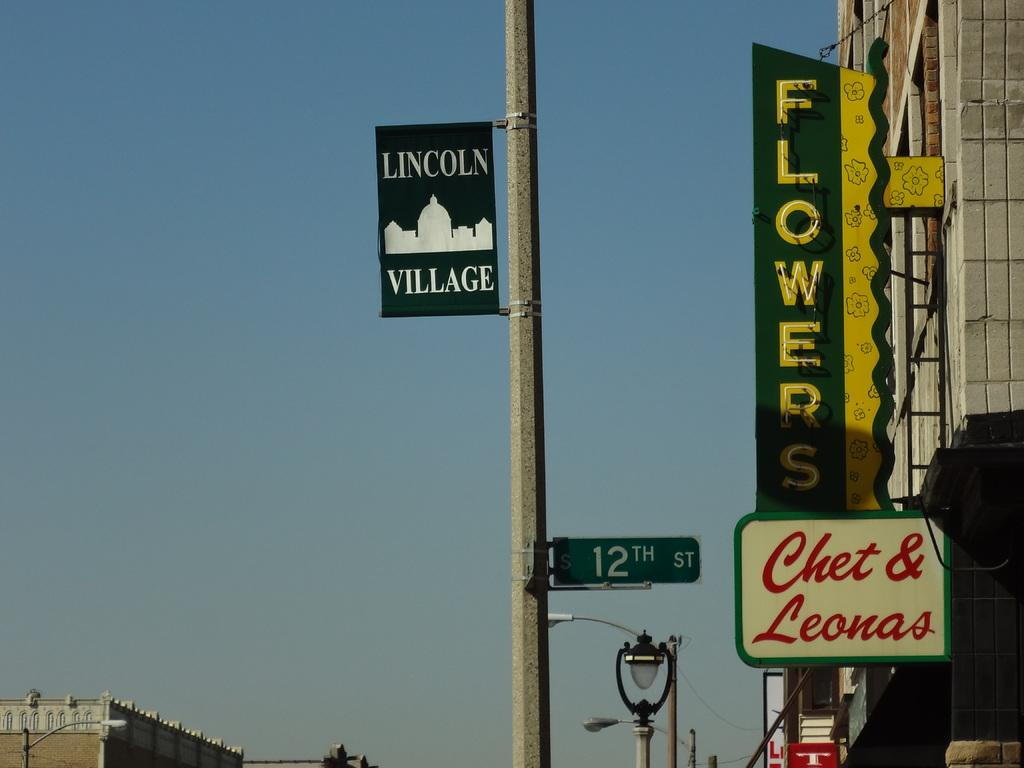<image>
Summarize the visual content of the image. 12th street sign pole with a "Lincoln Village" sign attached to the pole. 